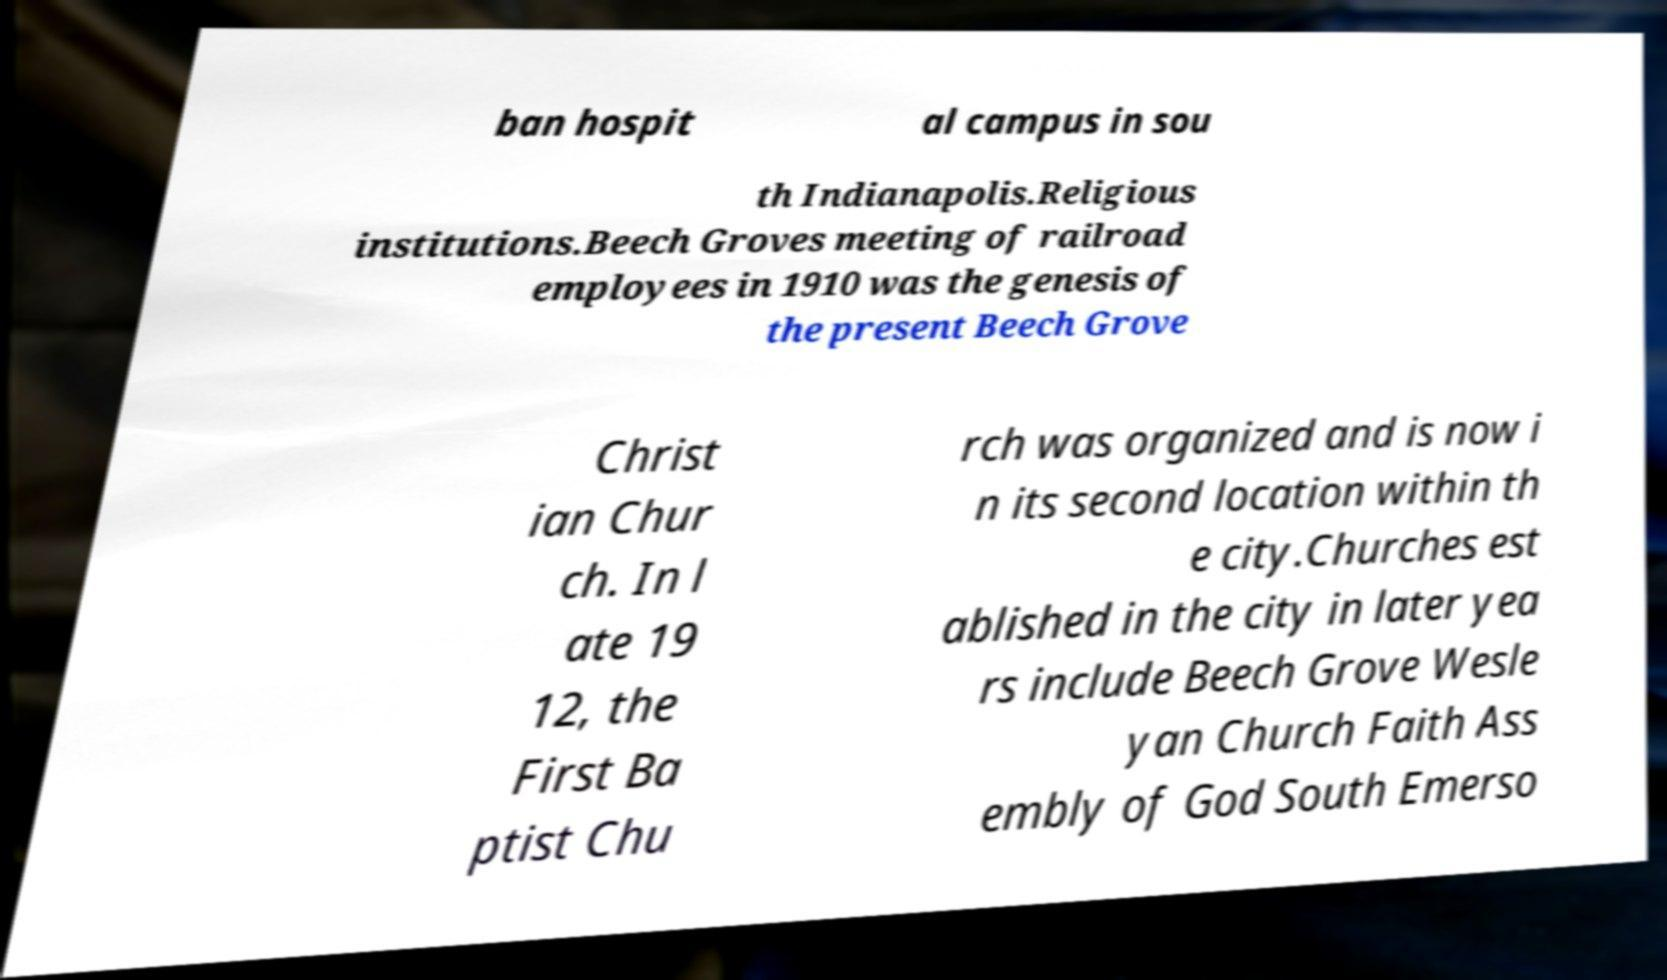What messages or text are displayed in this image? I need them in a readable, typed format. ban hospit al campus in sou th Indianapolis.Religious institutions.Beech Groves meeting of railroad employees in 1910 was the genesis of the present Beech Grove Christ ian Chur ch. In l ate 19 12, the First Ba ptist Chu rch was organized and is now i n its second location within th e city.Churches est ablished in the city in later yea rs include Beech Grove Wesle yan Church Faith Ass embly of God South Emerso 